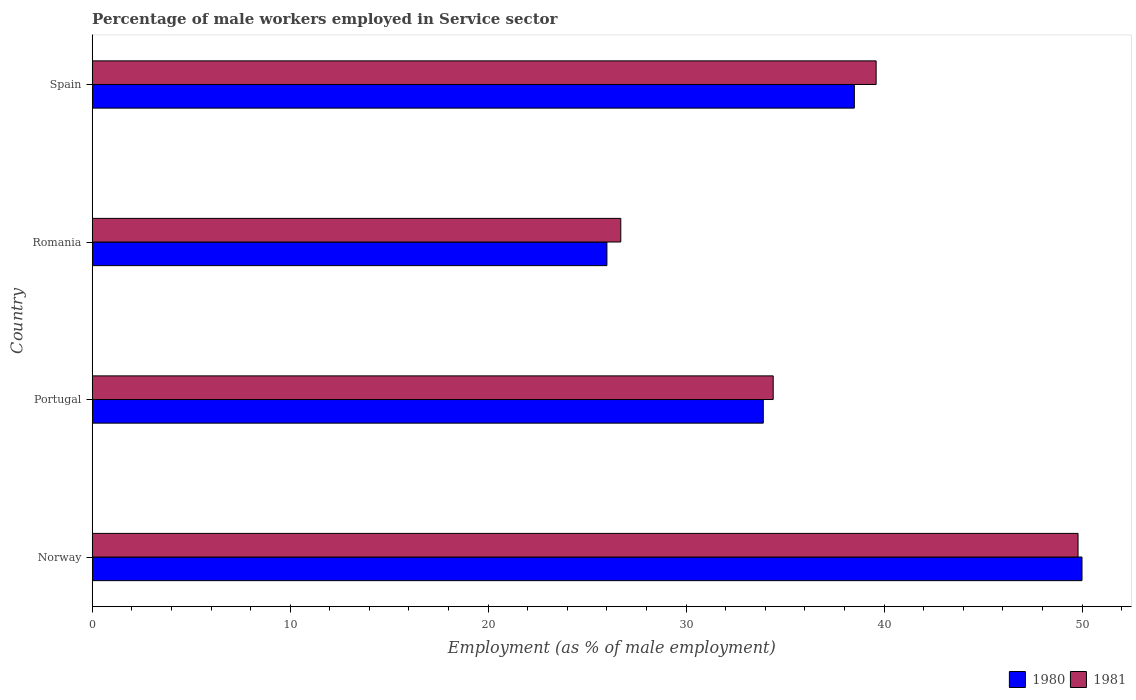How many different coloured bars are there?
Offer a terse response. 2. Are the number of bars per tick equal to the number of legend labels?
Provide a succinct answer. Yes. Are the number of bars on each tick of the Y-axis equal?
Provide a short and direct response. Yes. How many bars are there on the 1st tick from the top?
Provide a succinct answer. 2. What is the label of the 3rd group of bars from the top?
Offer a very short reply. Portugal. What is the percentage of male workers employed in Service sector in 1980 in Portugal?
Keep it short and to the point. 33.9. Across all countries, what is the maximum percentage of male workers employed in Service sector in 1980?
Your answer should be very brief. 50. In which country was the percentage of male workers employed in Service sector in 1981 minimum?
Keep it short and to the point. Romania. What is the total percentage of male workers employed in Service sector in 1981 in the graph?
Offer a very short reply. 150.5. What is the difference between the percentage of male workers employed in Service sector in 1981 in Romania and that in Spain?
Your answer should be very brief. -12.9. What is the difference between the percentage of male workers employed in Service sector in 1981 in Spain and the percentage of male workers employed in Service sector in 1980 in Romania?
Your answer should be compact. 13.6. What is the average percentage of male workers employed in Service sector in 1981 per country?
Your response must be concise. 37.62. What is the difference between the percentage of male workers employed in Service sector in 1981 and percentage of male workers employed in Service sector in 1980 in Spain?
Provide a succinct answer. 1.1. What is the ratio of the percentage of male workers employed in Service sector in 1981 in Romania to that in Spain?
Offer a terse response. 0.67. Is the percentage of male workers employed in Service sector in 1980 in Portugal less than that in Romania?
Your answer should be very brief. No. Is the difference between the percentage of male workers employed in Service sector in 1981 in Portugal and Romania greater than the difference between the percentage of male workers employed in Service sector in 1980 in Portugal and Romania?
Give a very brief answer. No. What is the difference between the highest and the second highest percentage of male workers employed in Service sector in 1981?
Offer a very short reply. 10.2. What is the difference between the highest and the lowest percentage of male workers employed in Service sector in 1980?
Give a very brief answer. 24. What does the 2nd bar from the top in Romania represents?
Ensure brevity in your answer.  1980. How many countries are there in the graph?
Your response must be concise. 4. What is the difference between two consecutive major ticks on the X-axis?
Provide a succinct answer. 10. Does the graph contain any zero values?
Provide a short and direct response. No. Does the graph contain grids?
Offer a terse response. No. What is the title of the graph?
Your response must be concise. Percentage of male workers employed in Service sector. What is the label or title of the X-axis?
Keep it short and to the point. Employment (as % of male employment). What is the label or title of the Y-axis?
Your answer should be compact. Country. What is the Employment (as % of male employment) in 1981 in Norway?
Make the answer very short. 49.8. What is the Employment (as % of male employment) of 1980 in Portugal?
Provide a succinct answer. 33.9. What is the Employment (as % of male employment) in 1981 in Portugal?
Provide a short and direct response. 34.4. What is the Employment (as % of male employment) of 1980 in Romania?
Offer a terse response. 26. What is the Employment (as % of male employment) in 1981 in Romania?
Give a very brief answer. 26.7. What is the Employment (as % of male employment) in 1980 in Spain?
Keep it short and to the point. 38.5. What is the Employment (as % of male employment) of 1981 in Spain?
Provide a short and direct response. 39.6. Across all countries, what is the maximum Employment (as % of male employment) in 1981?
Offer a very short reply. 49.8. Across all countries, what is the minimum Employment (as % of male employment) of 1980?
Give a very brief answer. 26. Across all countries, what is the minimum Employment (as % of male employment) in 1981?
Your response must be concise. 26.7. What is the total Employment (as % of male employment) in 1980 in the graph?
Your answer should be very brief. 148.4. What is the total Employment (as % of male employment) in 1981 in the graph?
Provide a short and direct response. 150.5. What is the difference between the Employment (as % of male employment) of 1981 in Norway and that in Portugal?
Your answer should be very brief. 15.4. What is the difference between the Employment (as % of male employment) of 1980 in Norway and that in Romania?
Make the answer very short. 24. What is the difference between the Employment (as % of male employment) in 1981 in Norway and that in Romania?
Your answer should be very brief. 23.1. What is the difference between the Employment (as % of male employment) in 1981 in Portugal and that in Romania?
Your answer should be very brief. 7.7. What is the difference between the Employment (as % of male employment) of 1980 in Portugal and that in Spain?
Ensure brevity in your answer.  -4.6. What is the difference between the Employment (as % of male employment) of 1981 in Portugal and that in Spain?
Your answer should be very brief. -5.2. What is the difference between the Employment (as % of male employment) in 1981 in Romania and that in Spain?
Offer a very short reply. -12.9. What is the difference between the Employment (as % of male employment) in 1980 in Norway and the Employment (as % of male employment) in 1981 in Portugal?
Ensure brevity in your answer.  15.6. What is the difference between the Employment (as % of male employment) in 1980 in Norway and the Employment (as % of male employment) in 1981 in Romania?
Offer a very short reply. 23.3. What is the difference between the Employment (as % of male employment) of 1980 in Norway and the Employment (as % of male employment) of 1981 in Spain?
Your answer should be compact. 10.4. What is the difference between the Employment (as % of male employment) in 1980 in Portugal and the Employment (as % of male employment) in 1981 in Spain?
Your response must be concise. -5.7. What is the average Employment (as % of male employment) in 1980 per country?
Keep it short and to the point. 37.1. What is the average Employment (as % of male employment) of 1981 per country?
Offer a terse response. 37.62. What is the difference between the Employment (as % of male employment) in 1980 and Employment (as % of male employment) in 1981 in Norway?
Your answer should be compact. 0.2. What is the ratio of the Employment (as % of male employment) in 1980 in Norway to that in Portugal?
Your response must be concise. 1.47. What is the ratio of the Employment (as % of male employment) of 1981 in Norway to that in Portugal?
Make the answer very short. 1.45. What is the ratio of the Employment (as % of male employment) in 1980 in Norway to that in Romania?
Your answer should be very brief. 1.92. What is the ratio of the Employment (as % of male employment) of 1981 in Norway to that in Romania?
Your response must be concise. 1.87. What is the ratio of the Employment (as % of male employment) of 1980 in Norway to that in Spain?
Offer a very short reply. 1.3. What is the ratio of the Employment (as % of male employment) in 1981 in Norway to that in Spain?
Provide a succinct answer. 1.26. What is the ratio of the Employment (as % of male employment) in 1980 in Portugal to that in Romania?
Provide a short and direct response. 1.3. What is the ratio of the Employment (as % of male employment) of 1981 in Portugal to that in Romania?
Offer a very short reply. 1.29. What is the ratio of the Employment (as % of male employment) of 1980 in Portugal to that in Spain?
Keep it short and to the point. 0.88. What is the ratio of the Employment (as % of male employment) of 1981 in Portugal to that in Spain?
Offer a terse response. 0.87. What is the ratio of the Employment (as % of male employment) in 1980 in Romania to that in Spain?
Provide a succinct answer. 0.68. What is the ratio of the Employment (as % of male employment) in 1981 in Romania to that in Spain?
Your answer should be compact. 0.67. What is the difference between the highest and the second highest Employment (as % of male employment) of 1980?
Offer a terse response. 11.5. What is the difference between the highest and the lowest Employment (as % of male employment) of 1980?
Offer a terse response. 24. What is the difference between the highest and the lowest Employment (as % of male employment) in 1981?
Offer a terse response. 23.1. 